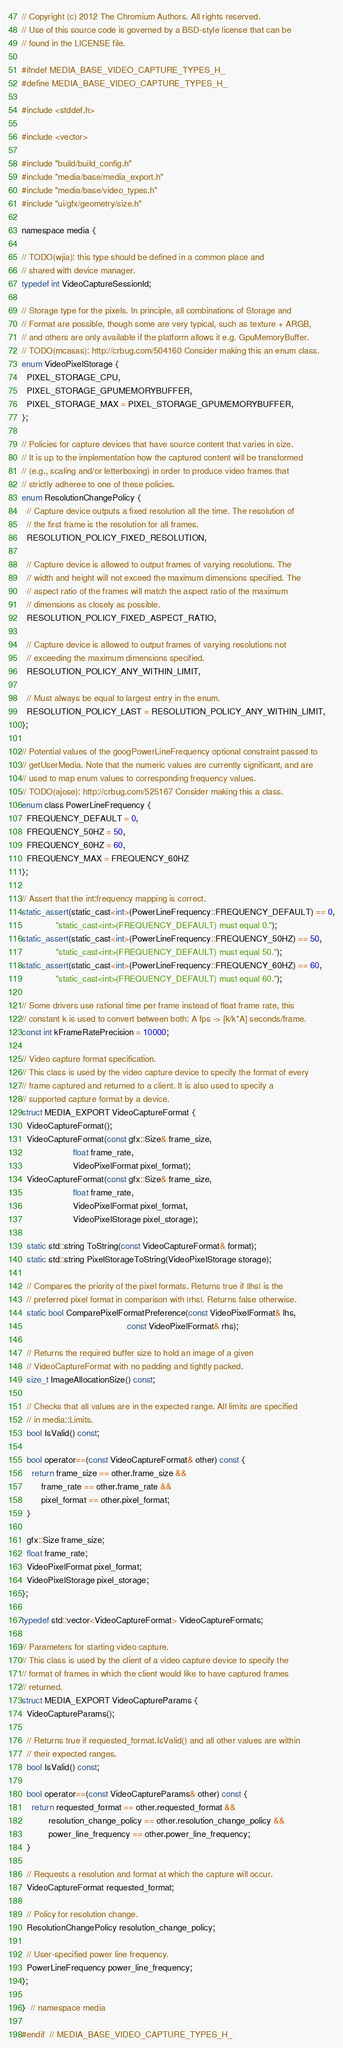Convert code to text. <code><loc_0><loc_0><loc_500><loc_500><_C_>// Copyright (c) 2012 The Chromium Authors. All rights reserved.
// Use of this source code is governed by a BSD-style license that can be
// found in the LICENSE file.

#ifndef MEDIA_BASE_VIDEO_CAPTURE_TYPES_H_
#define MEDIA_BASE_VIDEO_CAPTURE_TYPES_H_

#include <stddef.h>

#include <vector>

#include "build/build_config.h"
#include "media/base/media_export.h"
#include "media/base/video_types.h"
#include "ui/gfx/geometry/size.h"

namespace media {

// TODO(wjia): this type should be defined in a common place and
// shared with device manager.
typedef int VideoCaptureSessionId;

// Storage type for the pixels. In principle, all combinations of Storage and
// Format are possible, though some are very typical, such as texture + ARGB,
// and others are only available if the platform allows it e.g. GpuMemoryBuffer.
// TODO(mcasas): http://crbug.com/504160 Consider making this an enum class.
enum VideoPixelStorage {
  PIXEL_STORAGE_CPU,
  PIXEL_STORAGE_GPUMEMORYBUFFER,
  PIXEL_STORAGE_MAX = PIXEL_STORAGE_GPUMEMORYBUFFER,
};

// Policies for capture devices that have source content that varies in size.
// It is up to the implementation how the captured content will be transformed
// (e.g., scaling and/or letterboxing) in order to produce video frames that
// strictly adheree to one of these policies.
enum ResolutionChangePolicy {
  // Capture device outputs a fixed resolution all the time. The resolution of
  // the first frame is the resolution for all frames.
  RESOLUTION_POLICY_FIXED_RESOLUTION,

  // Capture device is allowed to output frames of varying resolutions. The
  // width and height will not exceed the maximum dimensions specified. The
  // aspect ratio of the frames will match the aspect ratio of the maximum
  // dimensions as closely as possible.
  RESOLUTION_POLICY_FIXED_ASPECT_RATIO,

  // Capture device is allowed to output frames of varying resolutions not
  // exceeding the maximum dimensions specified.
  RESOLUTION_POLICY_ANY_WITHIN_LIMIT,

  // Must always be equal to largest entry in the enum.
  RESOLUTION_POLICY_LAST = RESOLUTION_POLICY_ANY_WITHIN_LIMIT,
};

// Potential values of the googPowerLineFrequency optional constraint passed to
// getUserMedia. Note that the numeric values are currently significant, and are
// used to map enum values to corresponding frequency values.
// TODO(ajose): http://crbug.com/525167 Consider making this a class.
enum class PowerLineFrequency {
  FREQUENCY_DEFAULT = 0,
  FREQUENCY_50HZ = 50,
  FREQUENCY_60HZ = 60,
  FREQUENCY_MAX = FREQUENCY_60HZ
};

// Assert that the int:frequency mapping is correct.
static_assert(static_cast<int>(PowerLineFrequency::FREQUENCY_DEFAULT) == 0,
              "static_cast<int>(FREQUENCY_DEFAULT) must equal 0.");
static_assert(static_cast<int>(PowerLineFrequency::FREQUENCY_50HZ) == 50,
              "static_cast<int>(FREQUENCY_DEFAULT) must equal 50.");
static_assert(static_cast<int>(PowerLineFrequency::FREQUENCY_60HZ) == 60,
              "static_cast<int>(FREQUENCY_DEFAULT) must equal 60.");

// Some drivers use rational time per frame instead of float frame rate, this
// constant k is used to convert between both: A fps -> [k/k*A] seconds/frame.
const int kFrameRatePrecision = 10000;

// Video capture format specification.
// This class is used by the video capture device to specify the format of every
// frame captured and returned to a client. It is also used to specify a
// supported capture format by a device.
struct MEDIA_EXPORT VideoCaptureFormat {
  VideoCaptureFormat();
  VideoCaptureFormat(const gfx::Size& frame_size,
                     float frame_rate,
                     VideoPixelFormat pixel_format);
  VideoCaptureFormat(const gfx::Size& frame_size,
                     float frame_rate,
                     VideoPixelFormat pixel_format,
                     VideoPixelStorage pixel_storage);

  static std::string ToString(const VideoCaptureFormat& format);
  static std::string PixelStorageToString(VideoPixelStorage storage);

  // Compares the priority of the pixel formats. Returns true if |lhs| is the
  // preferred pixel format in comparison with |rhs|. Returns false otherwise.
  static bool ComparePixelFormatPreference(const VideoPixelFormat& lhs,
                                           const VideoPixelFormat& rhs);

  // Returns the required buffer size to hold an image of a given
  // VideoCaptureFormat with no padding and tightly packed.
  size_t ImageAllocationSize() const;

  // Checks that all values are in the expected range. All limits are specified
  // in media::Limits.
  bool IsValid() const;

  bool operator==(const VideoCaptureFormat& other) const {
    return frame_size == other.frame_size &&
        frame_rate == other.frame_rate &&
        pixel_format == other.pixel_format;
  }

  gfx::Size frame_size;
  float frame_rate;
  VideoPixelFormat pixel_format;
  VideoPixelStorage pixel_storage;
};

typedef std::vector<VideoCaptureFormat> VideoCaptureFormats;

// Parameters for starting video capture.
// This class is used by the client of a video capture device to specify the
// format of frames in which the client would like to have captured frames
// returned.
struct MEDIA_EXPORT VideoCaptureParams {
  VideoCaptureParams();

  // Returns true if requested_format.IsValid() and all other values are within
  // their expected ranges.
  bool IsValid() const;

  bool operator==(const VideoCaptureParams& other) const {
    return requested_format == other.requested_format &&
           resolution_change_policy == other.resolution_change_policy &&
           power_line_frequency == other.power_line_frequency;
  }

  // Requests a resolution and format at which the capture will occur.
  VideoCaptureFormat requested_format;

  // Policy for resolution change.
  ResolutionChangePolicy resolution_change_policy;

  // User-specified power line frequency.
  PowerLineFrequency power_line_frequency;
};

}  // namespace media

#endif  // MEDIA_BASE_VIDEO_CAPTURE_TYPES_H_
</code> 